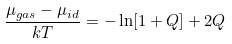<formula> <loc_0><loc_0><loc_500><loc_500>\frac { \mu _ { g a s } - \mu _ { i d } } { k T } = - \ln [ 1 + Q ] + 2 Q</formula> 